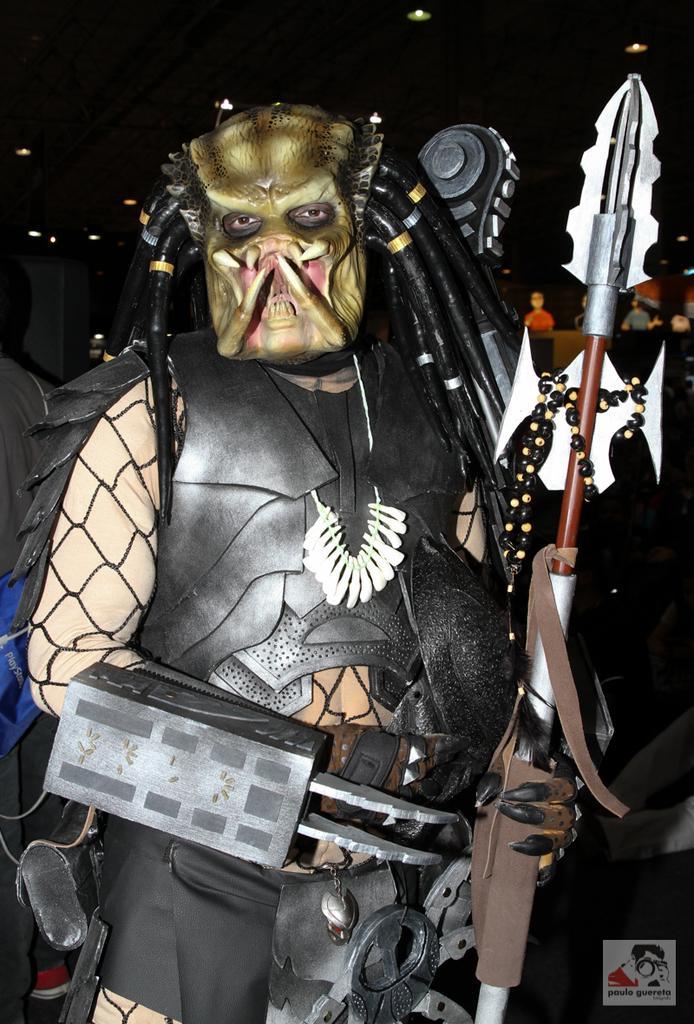Please provide a concise description of this image. This is the picture of a person in different costume and he is holding somethings in the hands. 